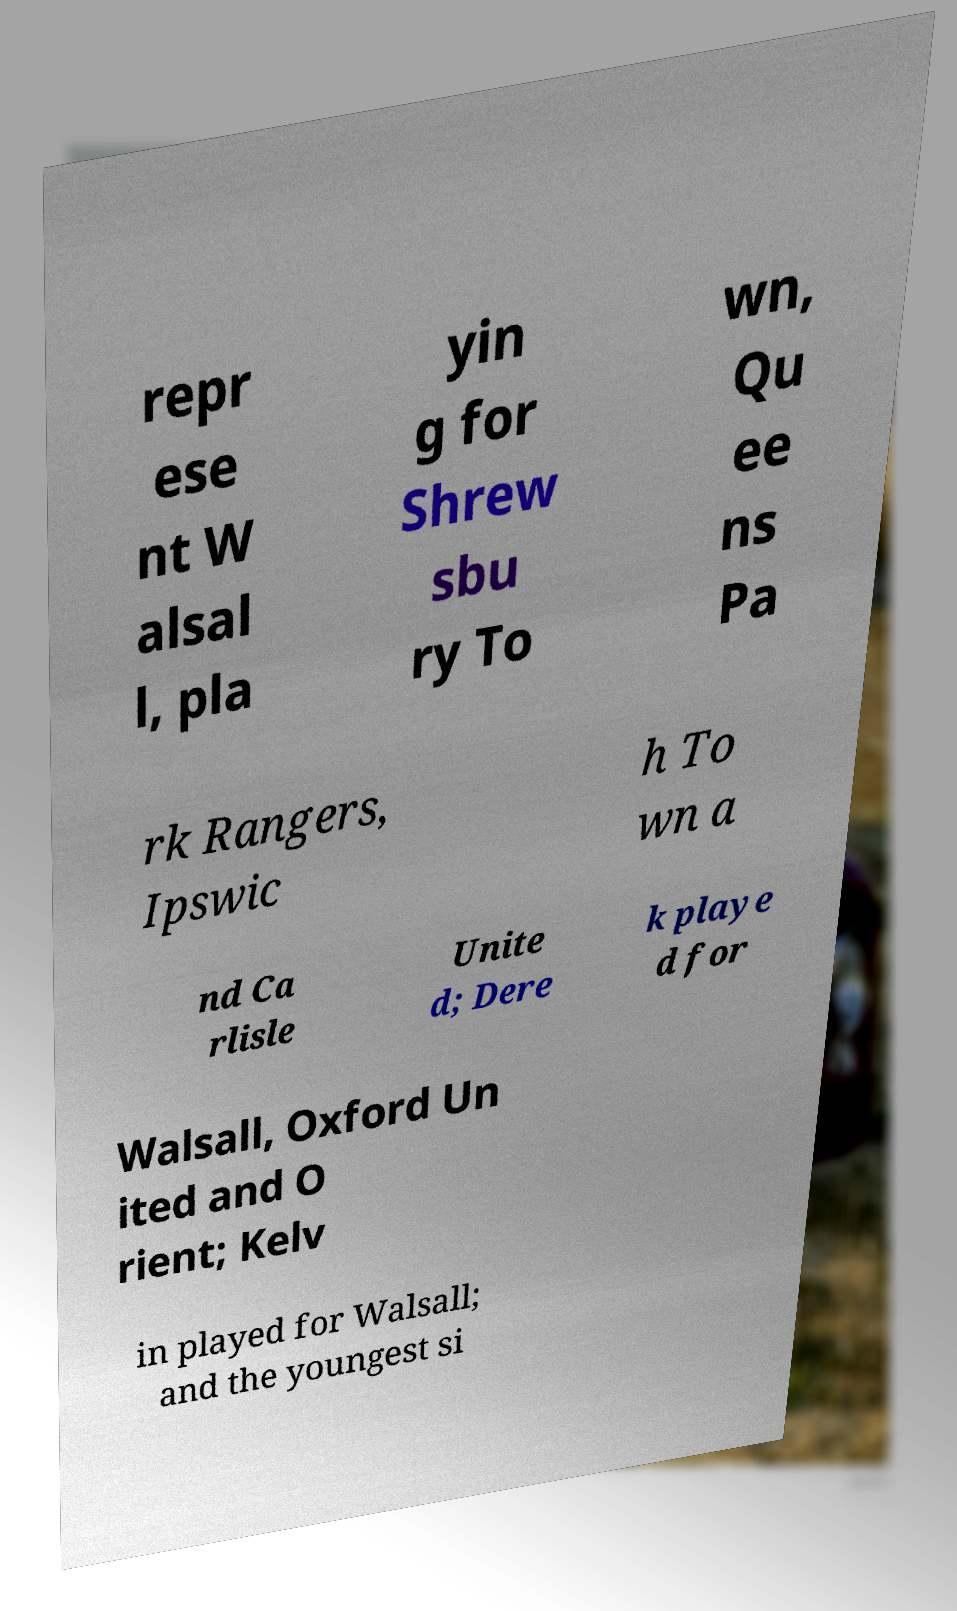Please read and relay the text visible in this image. What does it say? repr ese nt W alsal l, pla yin g for Shrew sbu ry To wn, Qu ee ns Pa rk Rangers, Ipswic h To wn a nd Ca rlisle Unite d; Dere k playe d for Walsall, Oxford Un ited and O rient; Kelv in played for Walsall; and the youngest si 